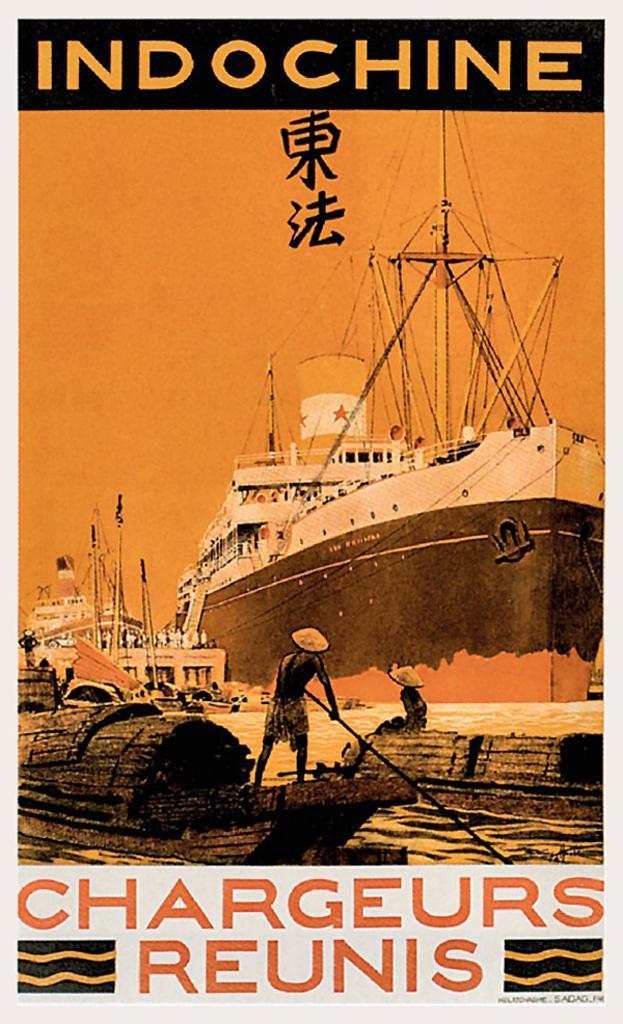How would you summarize this image in a sentence or two? This image consists of a poster. In which we can see a ship along with boats and few persons. And we can see the text. 